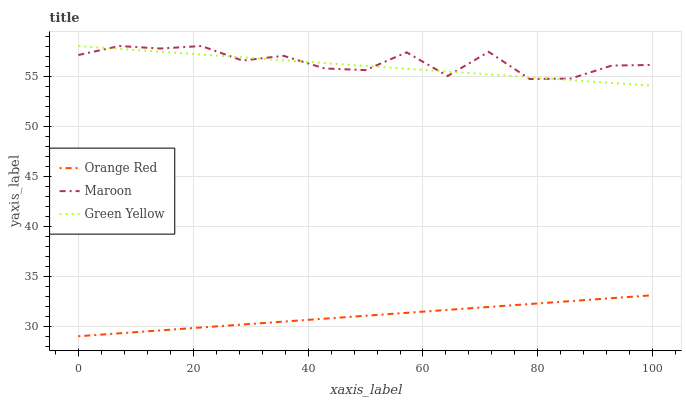Does Maroon have the minimum area under the curve?
Answer yes or no. No. Does Orange Red have the maximum area under the curve?
Answer yes or no. No. Is Orange Red the smoothest?
Answer yes or no. No. Is Orange Red the roughest?
Answer yes or no. No. Does Maroon have the lowest value?
Answer yes or no. No. Does Orange Red have the highest value?
Answer yes or no. No. Is Orange Red less than Green Yellow?
Answer yes or no. Yes. Is Green Yellow greater than Orange Red?
Answer yes or no. Yes. Does Orange Red intersect Green Yellow?
Answer yes or no. No. 